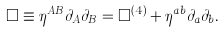<formula> <loc_0><loc_0><loc_500><loc_500>\Box \equiv \eta ^ { A B } \partial _ { A } \partial _ { B } = \Box ^ { ( 4 ) } + \eta ^ { a b } \partial _ { a } \partial _ { b } .</formula> 